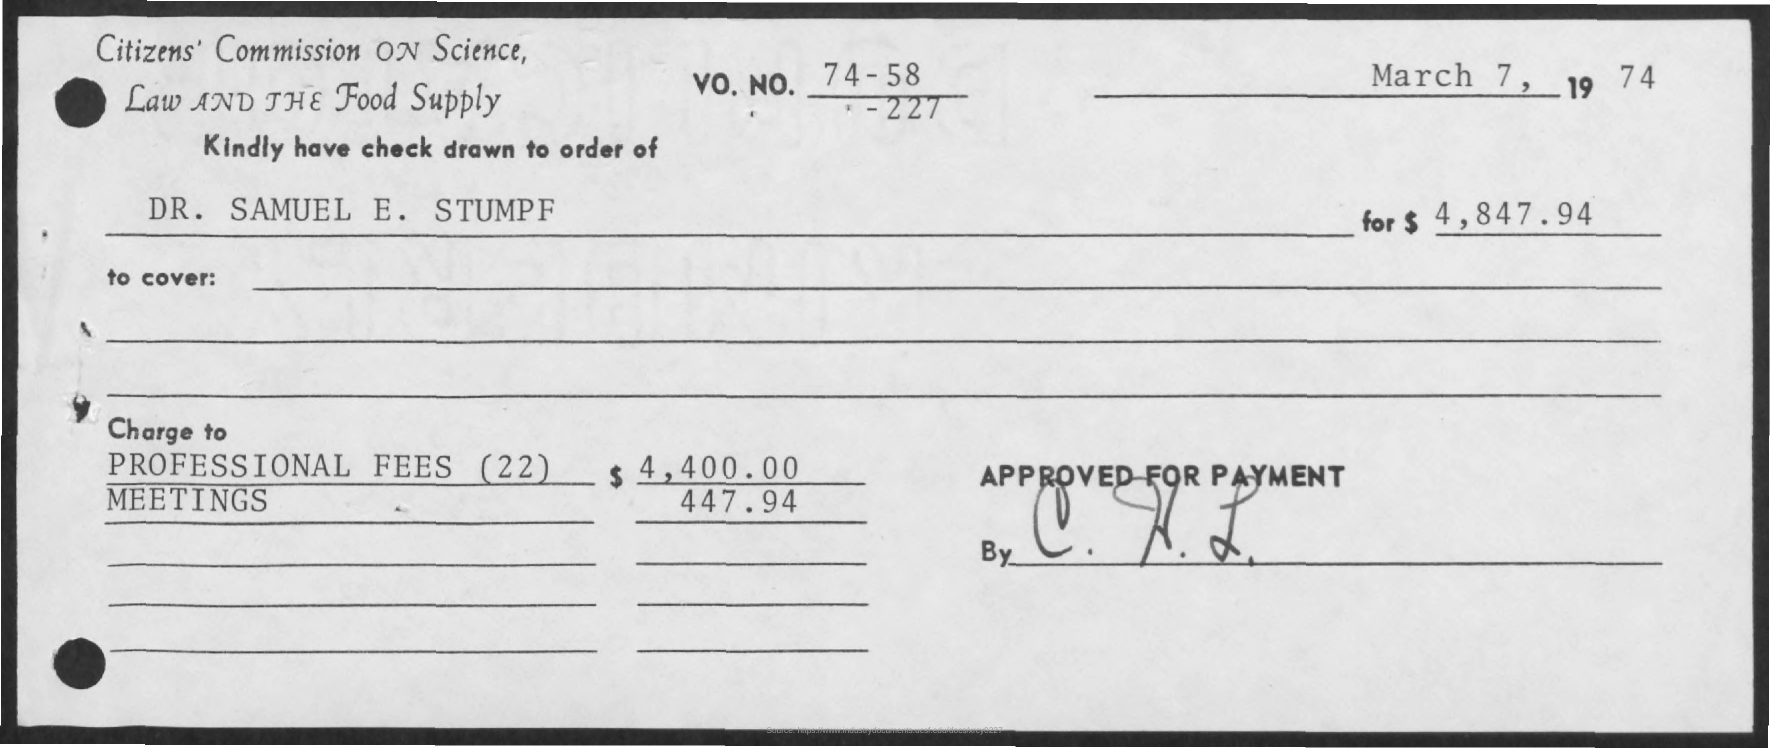What is the PROFESSIONAL FEES mentioned here?
Provide a short and direct response. $ 4,400.00. What is the name mentioned here?
Offer a terse response. Dr. Samuel E. Stumpf. 